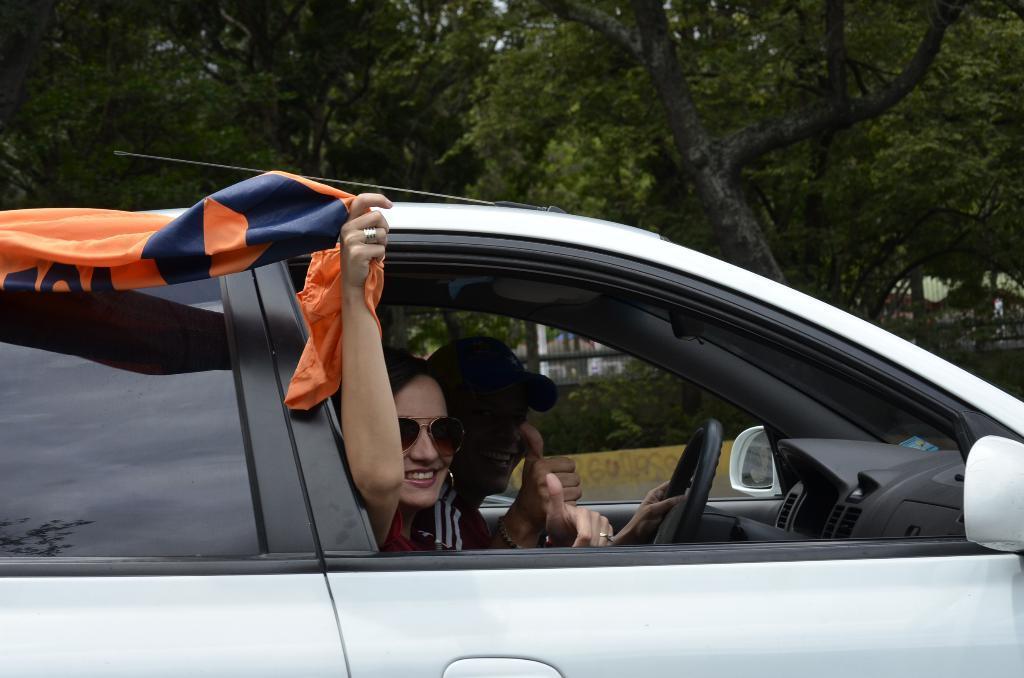In one or two sentences, can you explain what this image depicts? In this picture we can see there are two people sitting in a car and the woman is holding a cloth. Behind the vehicle, there are trees and the fence. 